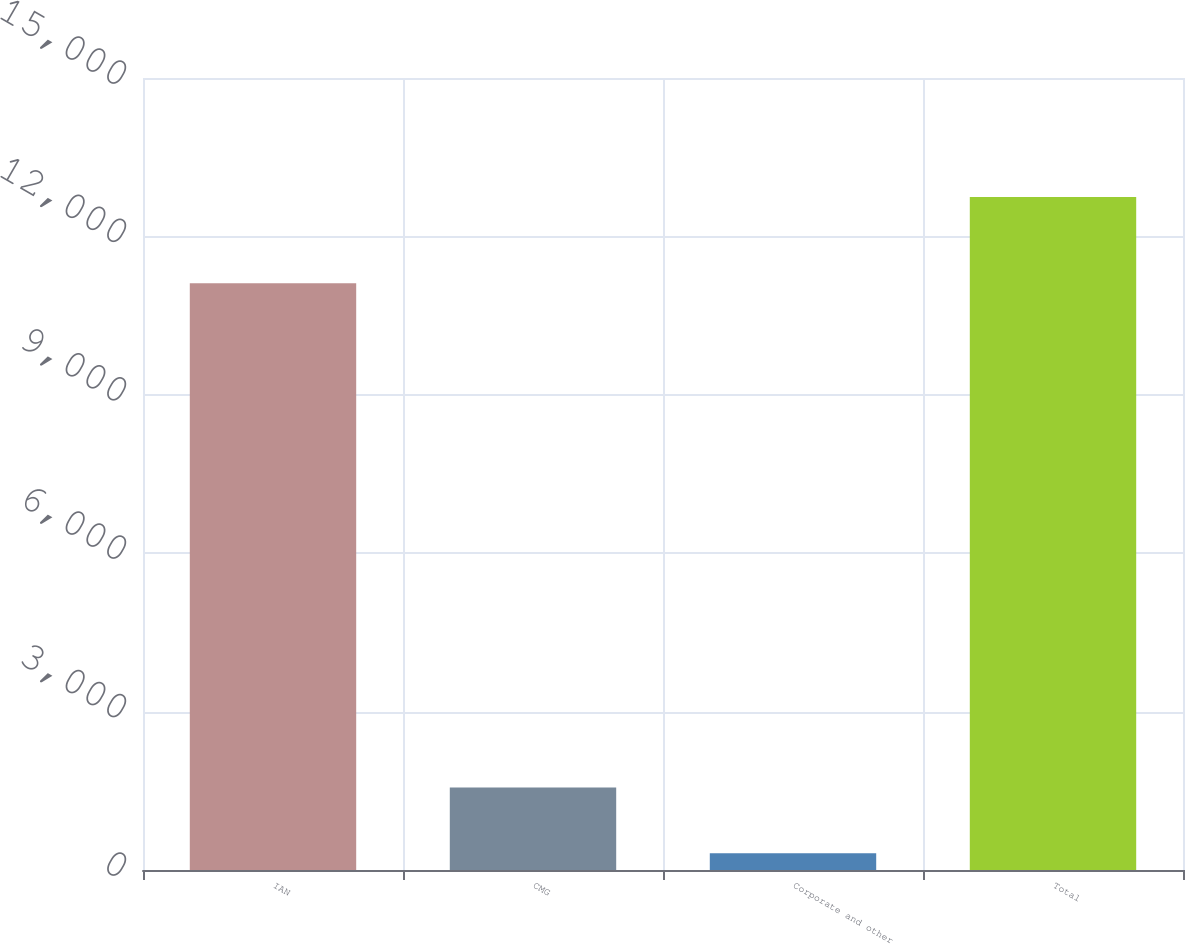<chart> <loc_0><loc_0><loc_500><loc_500><bar_chart><fcel>IAN<fcel>CMG<fcel>Corporate and other<fcel>Total<nl><fcel>11111.2<fcel>1562.27<fcel>319.5<fcel>12747.2<nl></chart> 